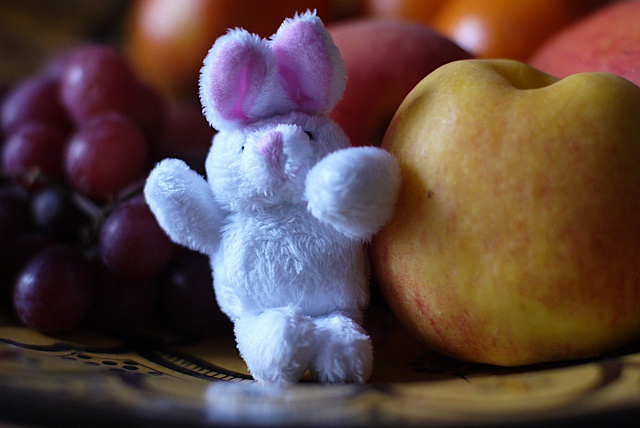Describe the objects in this image and their specific colors. I can see apple in black, maroon, olive, and tan tones and teddy bear in black, gray, lightblue, and purple tones in this image. 